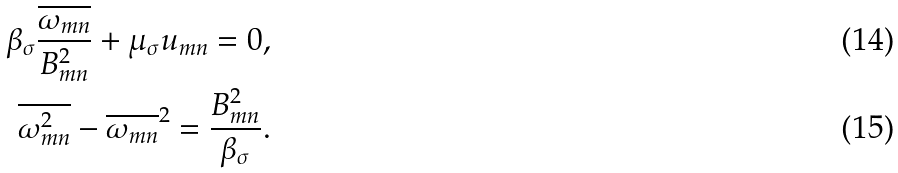<formula> <loc_0><loc_0><loc_500><loc_500>\beta _ { \sigma } \frac { \overline { \omega _ { m n } } } { B _ { m n } ^ { 2 } } + \mu _ { \sigma } u _ { m n } = 0 , \\ \overline { \omega _ { m n } ^ { 2 } } - \overline { \omega _ { m n } } ^ { 2 } = \frac { B _ { m n } ^ { 2 } } { \beta _ { \sigma } } .</formula> 